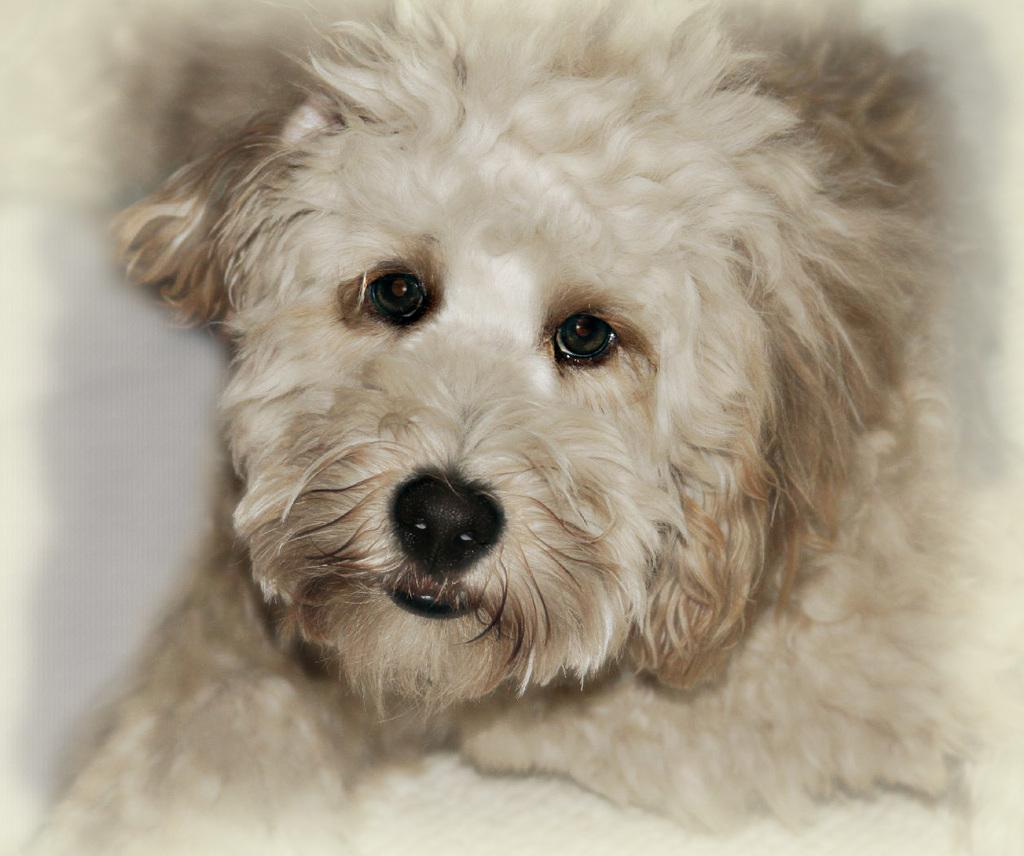What type of animal is present in the image? There is a dog in the image. Can you describe the color of the dog? The dog is white in color. What type of fuel is the dog using to keep warm in the image? The dog is not using any fuel to keep warm in the image, as dogs do not require fuel for warmth. 